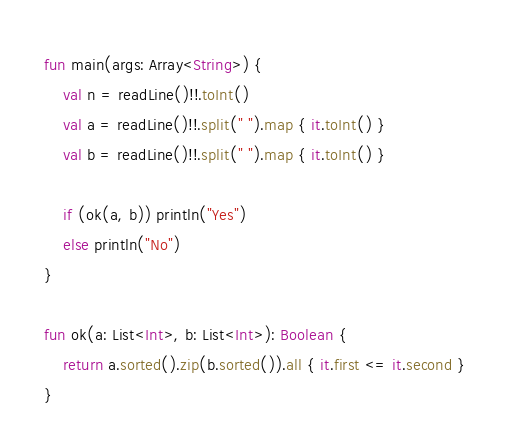Convert code to text. <code><loc_0><loc_0><loc_500><loc_500><_Kotlin_>fun main(args: Array<String>) {
    val n = readLine()!!.toInt()
    val a = readLine()!!.split(" ").map { it.toInt() }
    val b = readLine()!!.split(" ").map { it.toInt() }

    if (ok(a, b)) println("Yes")
    else println("No")
}

fun ok(a: List<Int>, b: List<Int>): Boolean {
    return a.sorted().zip(b.sorted()).all { it.first <= it.second }
}</code> 